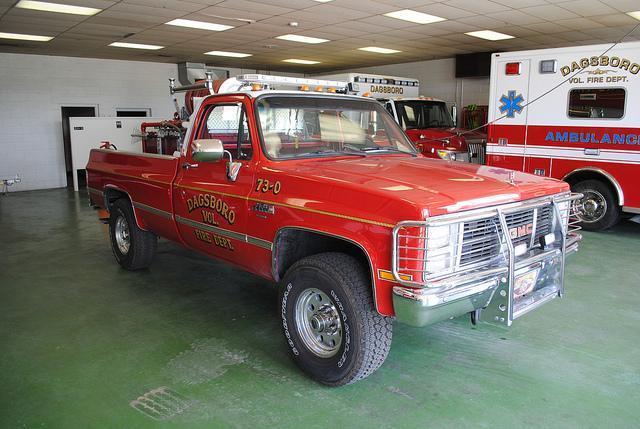How many trucks are there?
Give a very brief answer. 3. How many people are pulling luggage behind them?
Give a very brief answer. 0. 